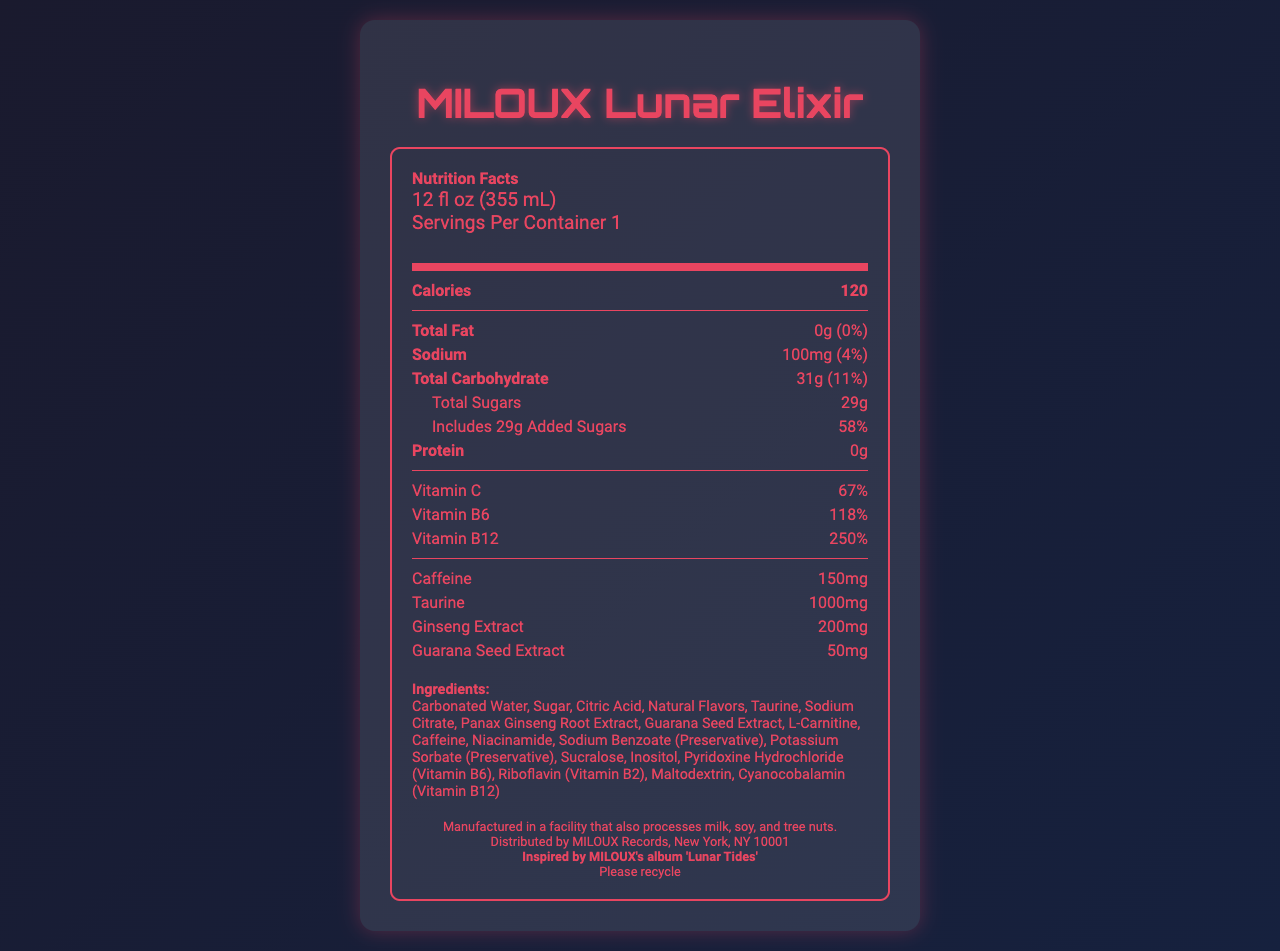what is the serving size for MILOUX Lunar Elixir? The serving size is explicitly stated in the document as "12 fl oz (355 mL)".
Answer: 12 fl oz (355 mL) how many calories are in one serving of MILOUX Lunar Elixir? The document lists the calories as 120 per serving.
Answer: 120 what percentage of daily value does the total carbohydrate content represent? The document states that the total carbohydrate content is 31g, which is 11% of the daily value.
Answer: 11% how much added sugars are included in MILOUX Lunar Elixir? The "Total Sugars" section specifies that the drink includes 29g of added sugars.
Answer: 29g what vitamins are present in MILOUX Lunar Elixir and their respective daily values? The document lists Vitamin C with a daily value of 67%, Vitamin B6 with 118%, and Vitamin B12 with 250%.
Answer: Vitamin C (67%), Vitamin B6 (118%), Vitamin B12 (250%) which extract is present in the smallest amount? A. Taurine B. Ginseng Extract C. Guarana Seed Extract The document mentions 50mg of Guarana Seed Extract, less than Ginseng Extract (200mg) and Taurine (1000mg).
Answer: C what is the main preservative used in MILOUX Lunar Elixir? The ingredient list includes "Sodium Benzoate (Preservative)" as one of the preservatives.
Answer: Sodium Benzoate is there any protein in MILOUX Lunar Elixir? The document lists the protein content as 0g.
Answer: No what allergens should consumers be aware of? The allergen information states that it is manufactured in a facility that also processes milk, soy, and tree nuts.
Answer: Milk, soy, and tree nuts how much caffeine is in one serving of MILOUX Lunar Elixir? The caffeine content is explicitly listed as 150mg in the document.
Answer: 150mg how much sodium is in MILOUX Lunar Elixir as a percentage of the daily value? The document lists the sodium content as 100mg, which is 4% of the daily value.
Answer: 4% where is MILOUX Lunar Elixir distributed? Distribution information indicates that the drink is distributed by MILOUX Records in New York, NY 10001.
Answer: New York, NY 10001 reflecting on MILOUX's 'Lunar Tides' album, which information connects the product to this album? The document mentions that the drink is "Inspired by MILOUX's album 'Lunar Tides'."
Answer: Limited edition info can it be determined if MILOUX Lunar Elixir is gluten-free from the document? The document does not provide any information about the presence or absence of gluten.
Answer: I don't know does MILOUX Lunar Elixir have any fat content? The document lists the total fat content as 0g, which is 0% of the daily value.
Answer: No which vitamin is present in the highest daily value percentage? A. Vitamin C B. Vitamin B6 C. Vitamin B12 The document shows Vitamin B12 with a daily value of 250%, higher than Vitamin C (67%) and Vitamin B6 (118%).
Answer: C summarize the main nutritional features of MILOUX Lunar Elixir The summary highlights essential nutritional content and special features related to its inspiration, vitamins, and key ingredients.
Answer: MILOUX Lunar Elixir is a limited edition energy drink inspired by MILOUX's album 'Lunar Tides'. It contains 120 calories per serving with 0g of fat, 100mg of sodium, and 31g of carbohydrates, including 29g of added sugars. Notably, it provides significant daily values of Vitamin C (67%), Vitamin B6 (118%), and Vitamin B12 (250%). Key ingredients include caffeine (150mg), taurine (1000mg), ginseng extract (200mg), and guarana seed extract (50mg). 